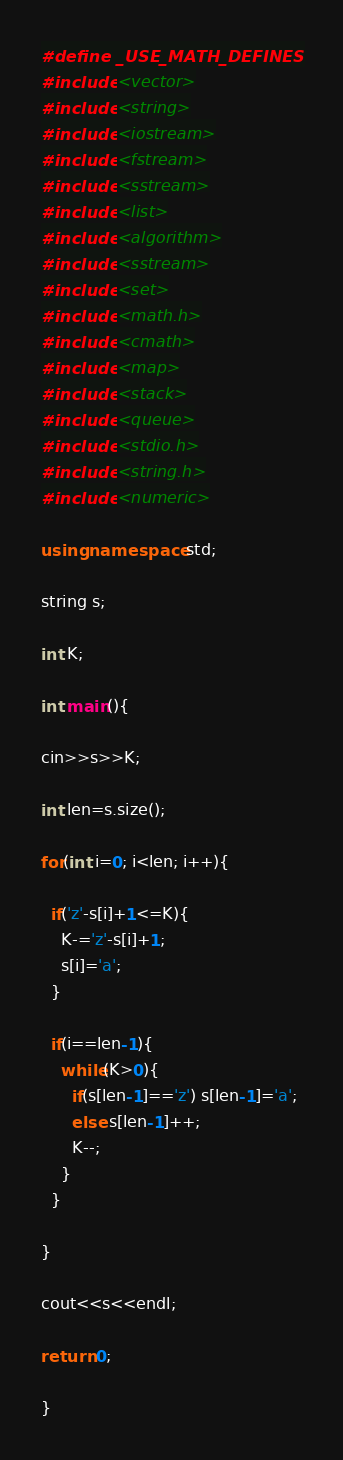Convert code to text. <code><loc_0><loc_0><loc_500><loc_500><_C++_>#define _USE_MATH_DEFINES
#include <vector>
#include <string>
#include <iostream>
#include <fstream>
#include <sstream>
#include <list>
#include <algorithm>
#include <sstream>
#include <set>
#include <math.h>
#include <cmath>
#include <map>
#include <stack>
#include <queue>
#include <stdio.h>
#include <string.h>
#include <numeric>
 
using namespace std;
 
string s;

int K;
 
int main(){

cin>>s>>K;

int len=s.size();

for(int i=0; i<len; i++){

  if('z'-s[i]+1<=K){
    K-='z'-s[i]+1;
    s[i]='a';
  }

  if(i==len-1){
    while(K>0){
      if(s[len-1]=='z') s[len-1]='a'; 
      else s[len-1]++;
      K--;
    }
  }

}

cout<<s<<endl;

return 0;
 
}</code> 